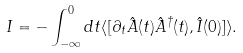<formula> <loc_0><loc_0><loc_500><loc_500>I = - \int _ { - \infty } ^ { 0 } d t \langle [ \partial _ { t } \hat { A } ( t ) \hat { A } ^ { \dagger } ( t ) , \hat { I } ( 0 ) ] \rangle .</formula> 